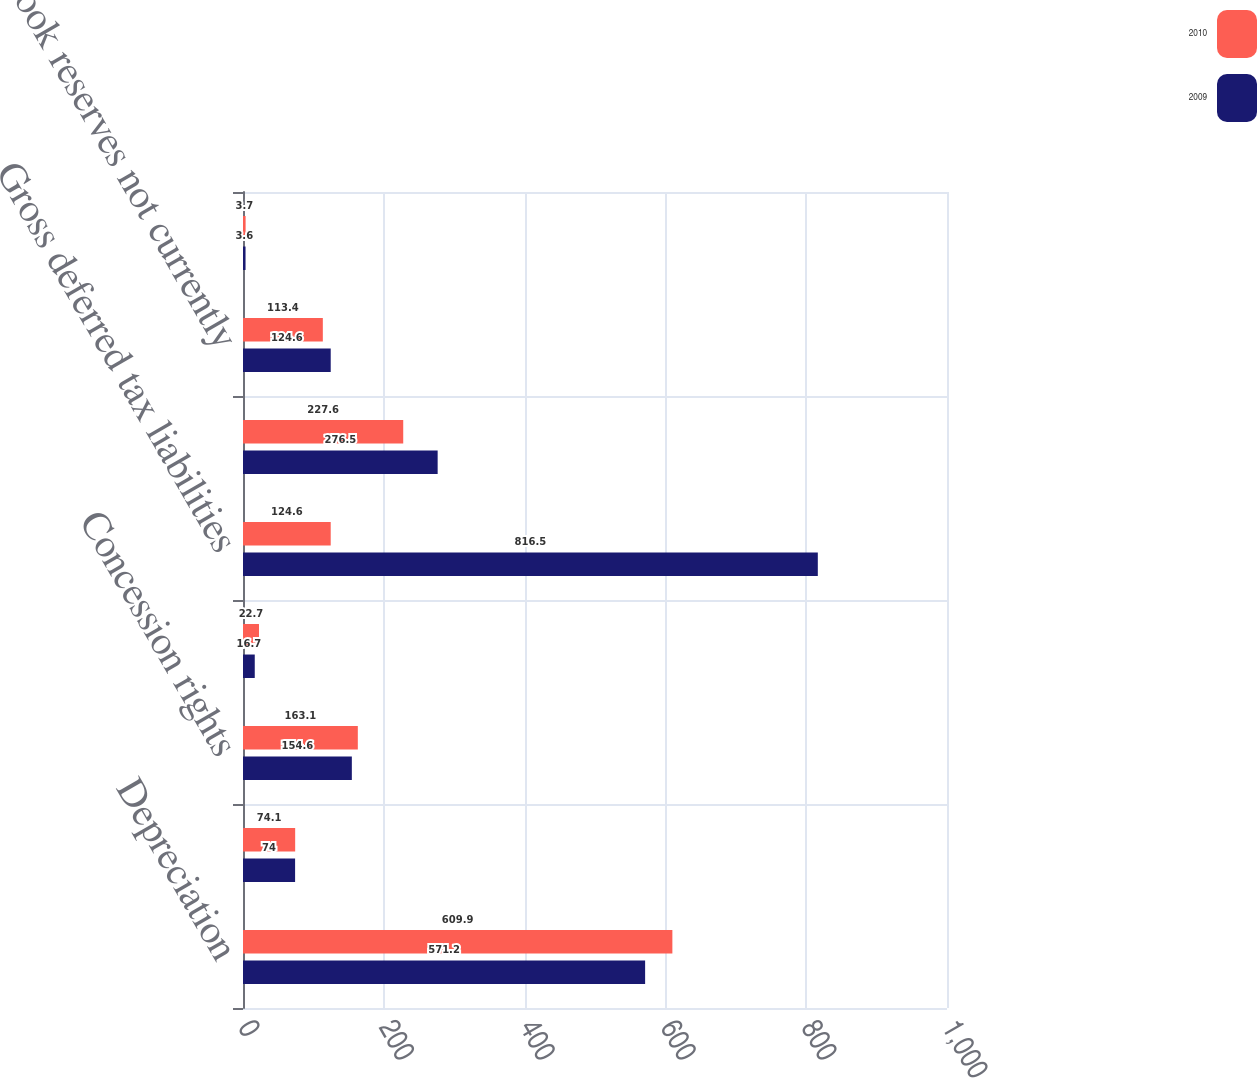Convert chart to OTSL. <chart><loc_0><loc_0><loc_500><loc_500><stacked_bar_chart><ecel><fcel>Depreciation<fcel>Investments<fcel>Concession rights<fcel>Other net<fcel>Gross deferred tax liabilities<fcel>Loss carryovers<fcel>Book reserves not currently<fcel>Vacation accrual<nl><fcel>2010<fcel>609.9<fcel>74.1<fcel>163.1<fcel>22.7<fcel>124.6<fcel>227.6<fcel>113.4<fcel>3.7<nl><fcel>2009<fcel>571.2<fcel>74<fcel>154.6<fcel>16.7<fcel>816.5<fcel>276.5<fcel>124.6<fcel>3.6<nl></chart> 